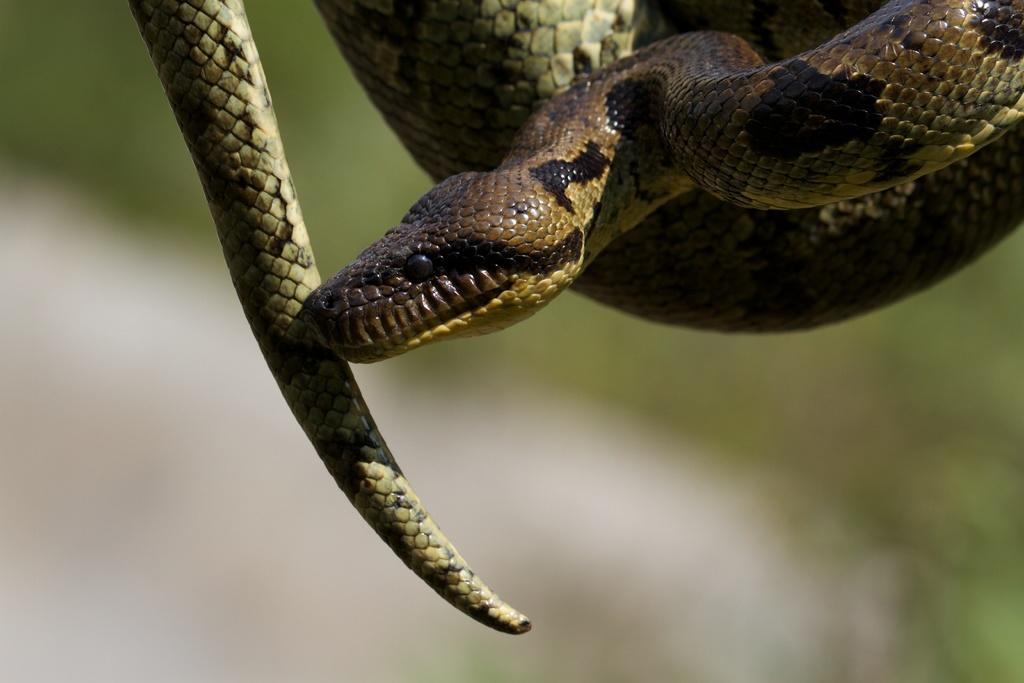Please provide a concise description of this image. In this image we can see a python. 